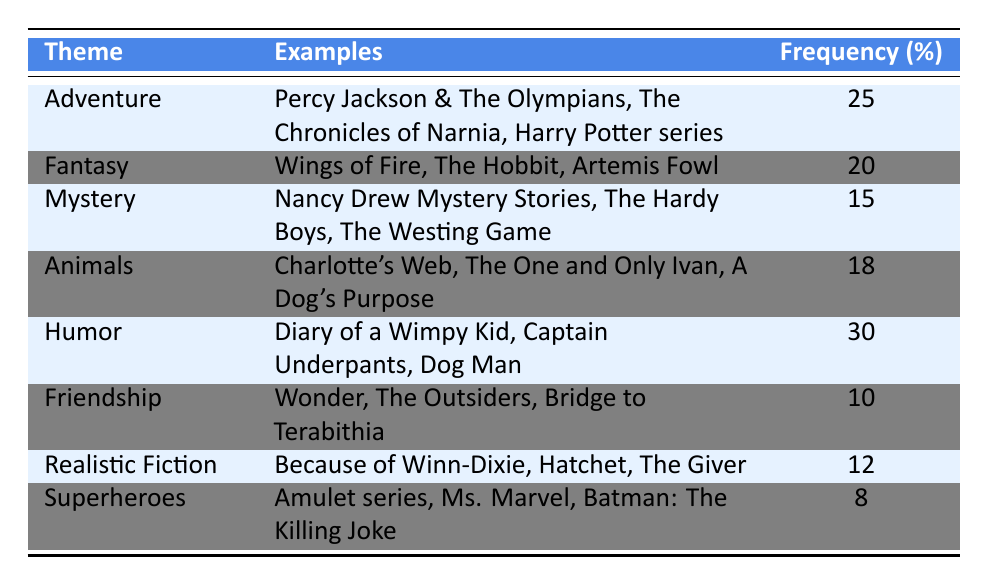What is the theme with the highest frequency? The table shows that Humor has the highest frequency at 30.
Answer: Humor How many themes have a frequency of 15 or more? By counting the themes with a frequency of at least 15, we find that there are five themes (Adventure, Fantasy, Mystery, Animals, Humor).
Answer: 5 What percentage of the total frequency does the Animals theme represent? The frequencies are 25 (Adventure) + 20 (Fantasy) + 15 (Mystery) + 18 (Animals) + 30 (Humor) + 10 (Friendship) + 12 (Realistic Fiction) + 8 (Superheroes) = 138. The frequency for Animals is 18, so the percentage is (18/138) * 100 ≈ 13.04%.
Answer: Approximately 13.04% Is there a theme related to Superheroes that has a higher frequency than 10? The frequency of Superheroes is 8, which does not exceed 10.
Answer: No Which theme has the lowest frequency and what is that frequency? The theme with the lowest frequency is Superheroes with a frequency of 8.
Answer: Superheroes, 8 What is the difference in frequency between the Adventure and Mystery themes? The frequency for Adventure is 25 and for Mystery is 15. The difference is 25 - 15 = 10.
Answer: 10 Which themes have a frequency less than 15, and how many are there? The themes with a frequency less than 15 are Friendship (10) and Superheroes (8), totaling 2 themes.
Answer: 2 If you combine the frequencies of the Fantasy and Animals themes, what is the total? The frequency of Fantasy is 20 and for Animals is 18. The total is 20 + 18 = 38.
Answer: 38 